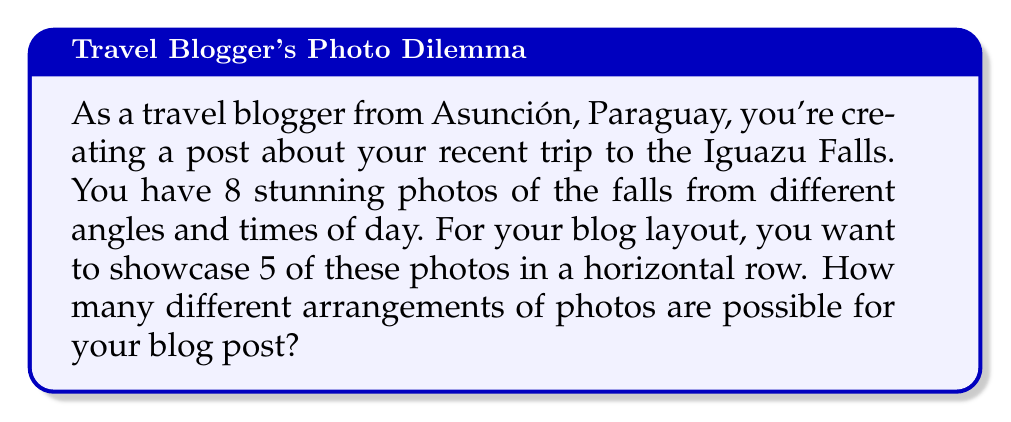Help me with this question. Let's approach this step-by-step:

1) This is a permutation problem because the order of the photos matters in the horizontal row.

2) We are selecting 5 photos out of 8 and arranging them in a specific order.

3) The formula for permutations without repetition is:

   $$P(n,r) = \frac{n!}{(n-r)!}$$

   Where $n$ is the total number of items to choose from, and $r$ is the number of items being chosen.

4) In this case, $n = 8$ (total photos) and $r = 5$ (photos in the row).

5) Plugging these values into our formula:

   $$P(8,5) = \frac{8!}{(8-5)!} = \frac{8!}{3!}$$

6) Expanding this:
   
   $$\frac{8 \times 7 \times 6 \times 5 \times 4 \times 3!}{3!}$$

7) The $3!$ cancels out in the numerator and denominator:

   $$8 \times 7 \times 6 \times 5 \times 4 = 6720$$

Thus, there are 6720 different possible arrangements of 5 photos chosen from 8 for the blog post.
Answer: 6720 